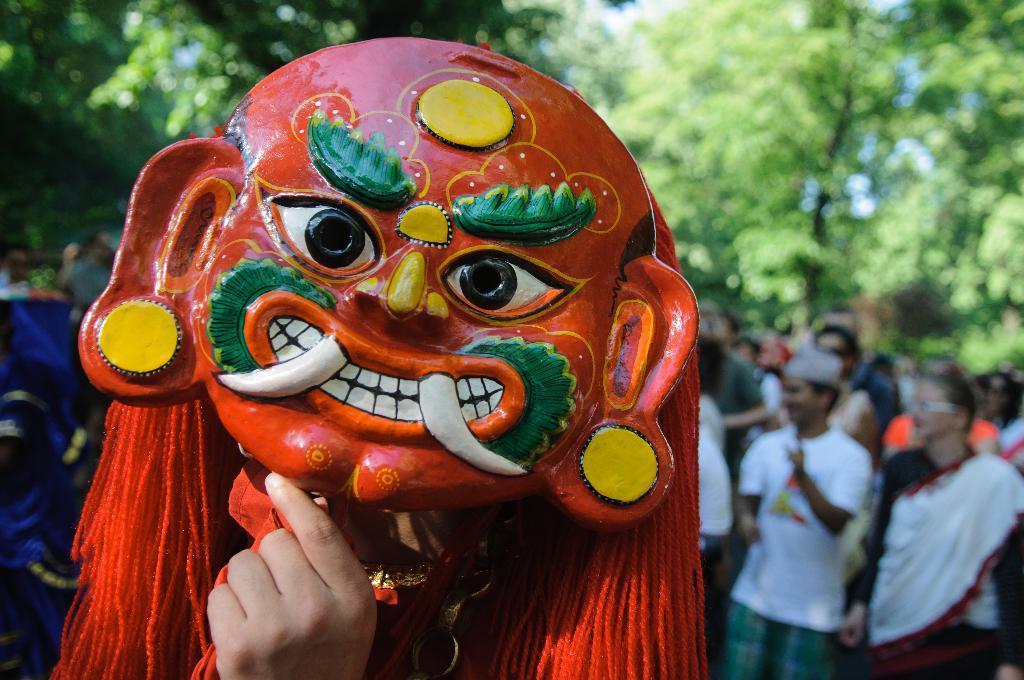Please provide a concise description of this image. As we can see in the image there are trees, few people here and there and face mask. 